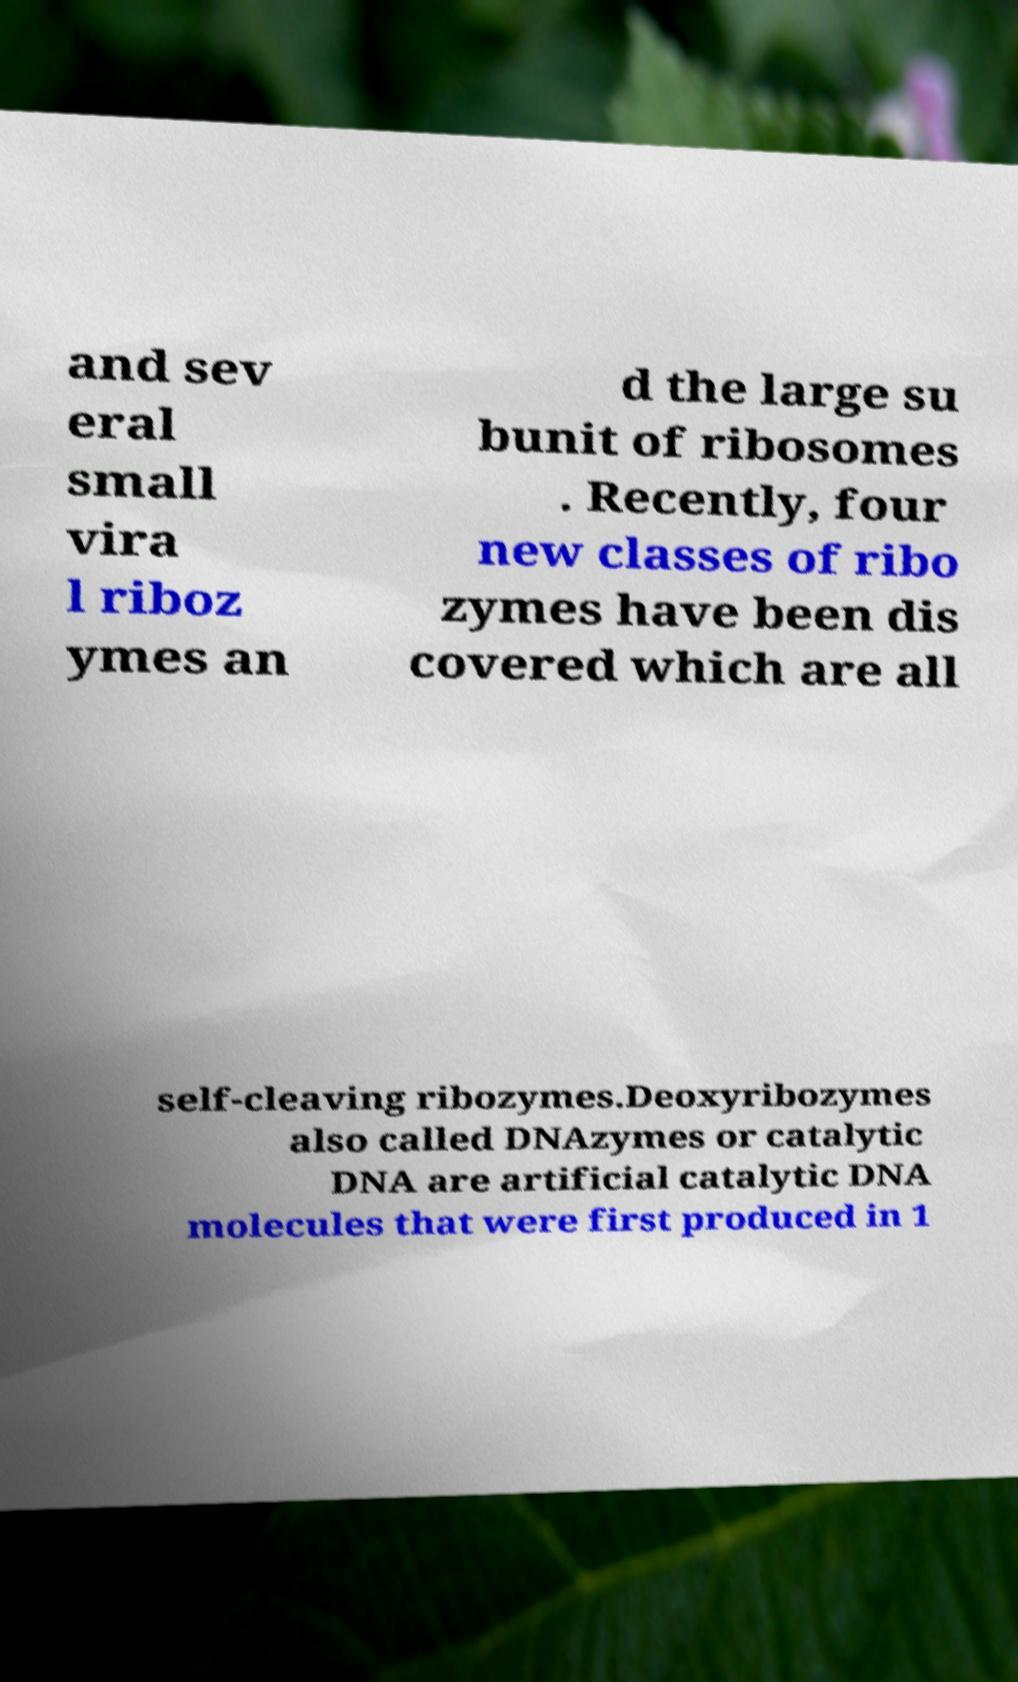For documentation purposes, I need the text within this image transcribed. Could you provide that? and sev eral small vira l riboz ymes an d the large su bunit of ribosomes . Recently, four new classes of ribo zymes have been dis covered which are all self-cleaving ribozymes.Deoxyribozymes also called DNAzymes or catalytic DNA are artificial catalytic DNA molecules that were first produced in 1 